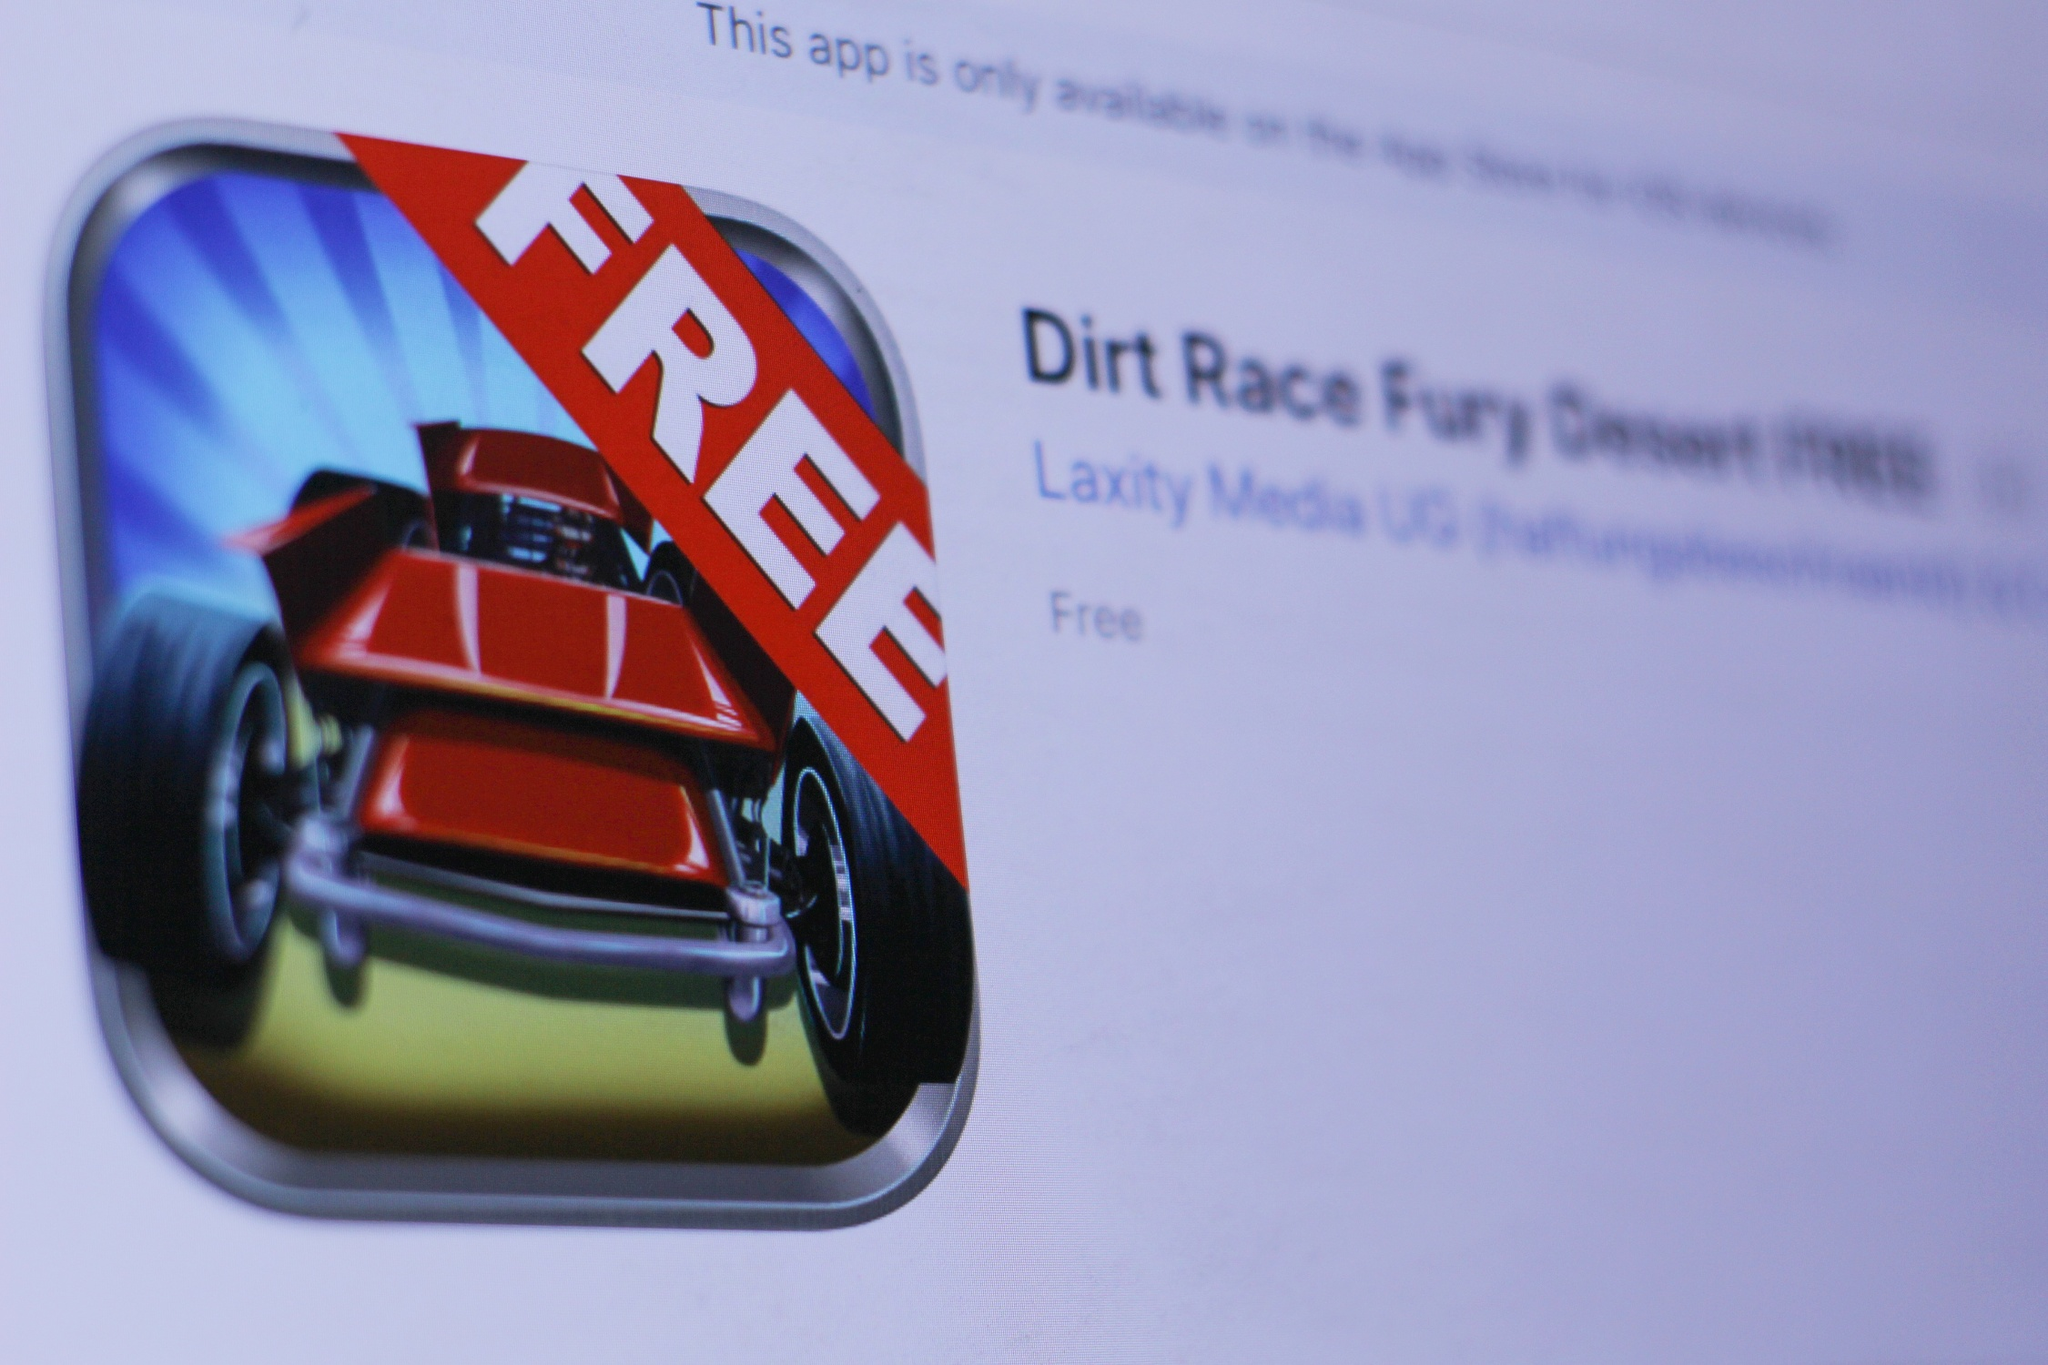Can you elaborate on the elements of the picture provided? The image offers a close-up perspective of a computer screen displaying an App Store page. The focal point of the screen is an application named 'Dirt Race Fury Desert FREE'. The app’s icon is particularly striking, with a dynamic red car set against a stark blue background. A bold red banner with the word 'FREE' in prominent white letters occupies a large portion of the icon, emphasizing that the app is available at no cost.

Below the app title, the developer 'Laxity Media UG' is indicated, ensuring users are aware of who created the app. Additionally, a note mentions that this app is exclusively available on the App Store for iOS devices, reinforcing its exclusivity. The overall design of the page is clean and user-friendly, with well-organized information to facilitate easy navigation and decision-making for users. 